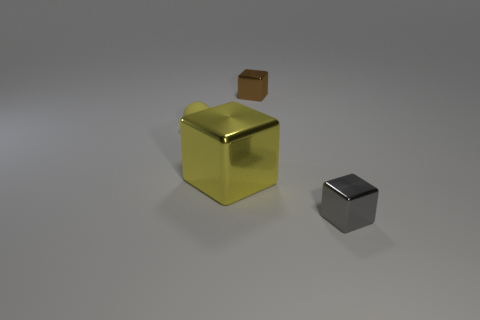Add 4 yellow things. How many objects exist? 8 Subtract all balls. How many objects are left? 3 Subtract 0 cyan cylinders. How many objects are left? 4 Subtract all big yellow objects. Subtract all matte spheres. How many objects are left? 2 Add 1 tiny yellow balls. How many tiny yellow balls are left? 2 Add 2 rubber balls. How many rubber balls exist? 3 